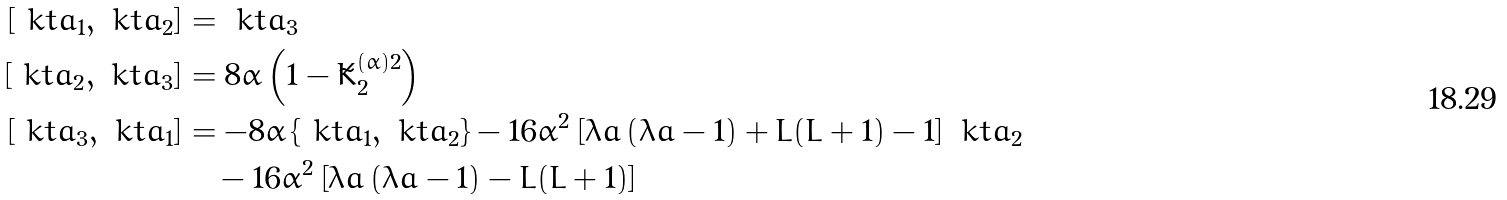<formula> <loc_0><loc_0><loc_500><loc_500>\left [ \ k t a _ { 1 } , \ k t a _ { 2 } \right ] & = \ k t a _ { 3 } \\ \left [ \ k t a _ { 2 } , \ k t a _ { 3 } \right ] & = 8 \alpha \left ( 1 - \tilde { K } ^ { ( \alpha ) 2 } _ { 2 } \right ) \\ \left [ \ k t a _ { 3 } , \ k t a _ { 1 } \right ] & = - 8 \alpha \left \{ \ k t a _ { 1 } , \ k t a _ { 2 } \right \} - 1 6 \alpha ^ { 2 } \left [ \lambda a \left ( \lambda a - 1 \right ) + L ( L + 1 ) - 1 \right ] \ k t a _ { 2 } \\ & \quad - 1 6 \alpha ^ { 2 } \left [ \lambda a \left ( \lambda a - 1 \right ) - L ( L + 1 ) \right ]</formula> 